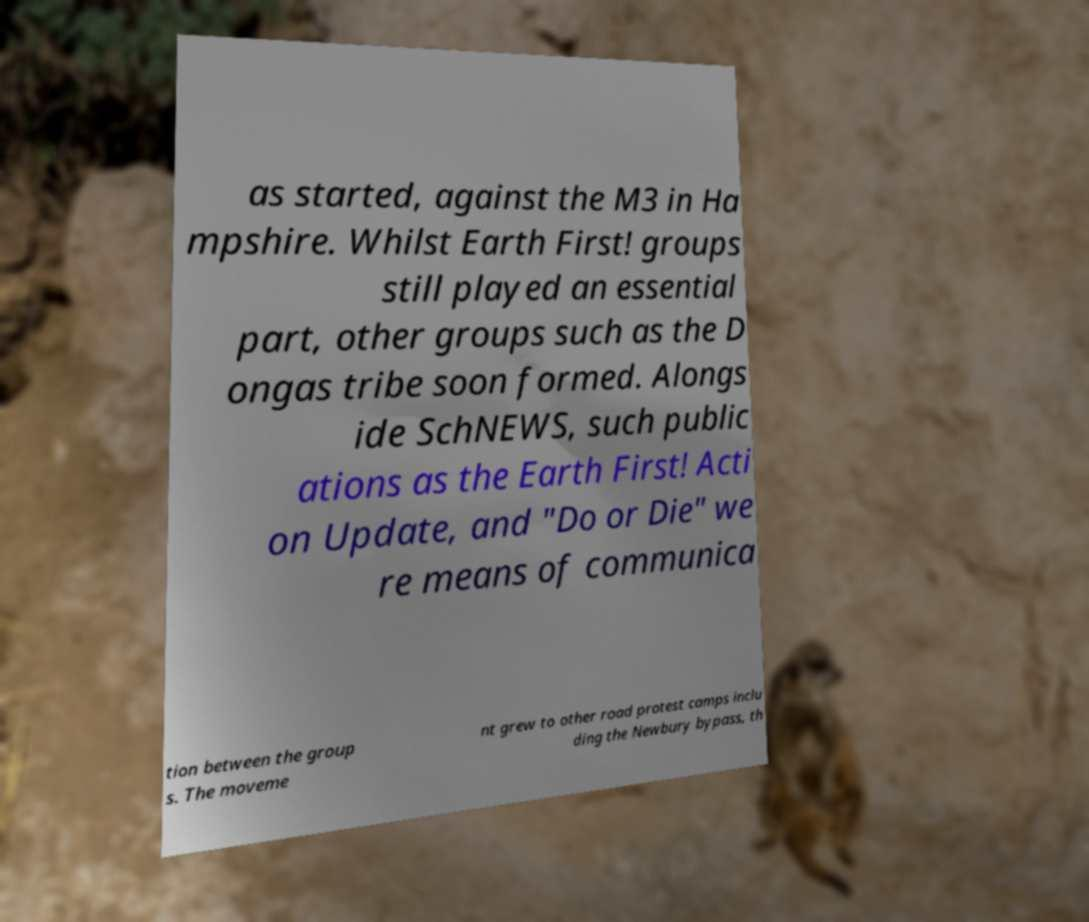Can you accurately transcribe the text from the provided image for me? as started, against the M3 in Ha mpshire. Whilst Earth First! groups still played an essential part, other groups such as the D ongas tribe soon formed. Alongs ide SchNEWS, such public ations as the Earth First! Acti on Update, and "Do or Die" we re means of communica tion between the group s. The moveme nt grew to other road protest camps inclu ding the Newbury bypass, th 